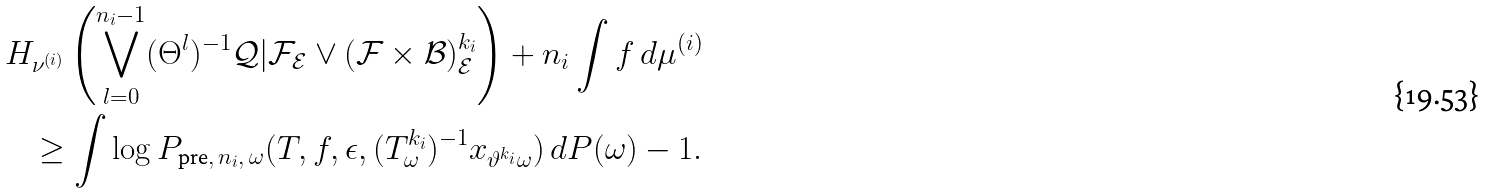<formula> <loc_0><loc_0><loc_500><loc_500>H _ { \nu ^ { ( i ) } } \left ( \bigvee _ { l = 0 } ^ { n _ { i } - 1 } ( \Theta ^ { l } ) ^ { - 1 } \mathcal { Q } | \mathcal { F } _ { \mathcal { E } } \vee ( \mathcal { F } \times \mathcal { B } ) ^ { k _ { i } } _ { \mathcal { E } } \right ) + n _ { i } \int f \, d \mu ^ { ( i ) } \\ \geq \int \log P _ { \text {pre} , \, n _ { i } , \, \omega } ( T , f , \epsilon , ( T _ { \omega } ^ { k _ { i } } ) ^ { - 1 } x _ { \vartheta ^ { k _ { i } } \omega } ) \, d P ( \omega ) - 1 .</formula> 